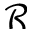Convert formula to latex. <formula><loc_0><loc_0><loc_500><loc_500>\mathcal { R }</formula> 